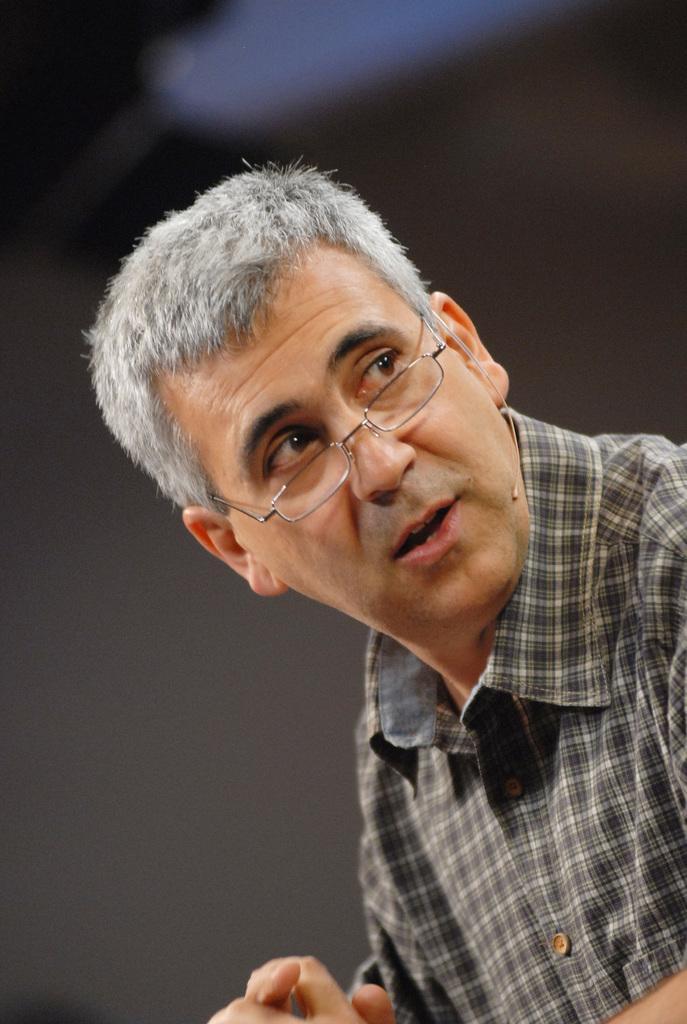Please provide a concise description of this image. In this picture we can see a man in the front, he wore a shirt and spectacles, there is a blurry background. 